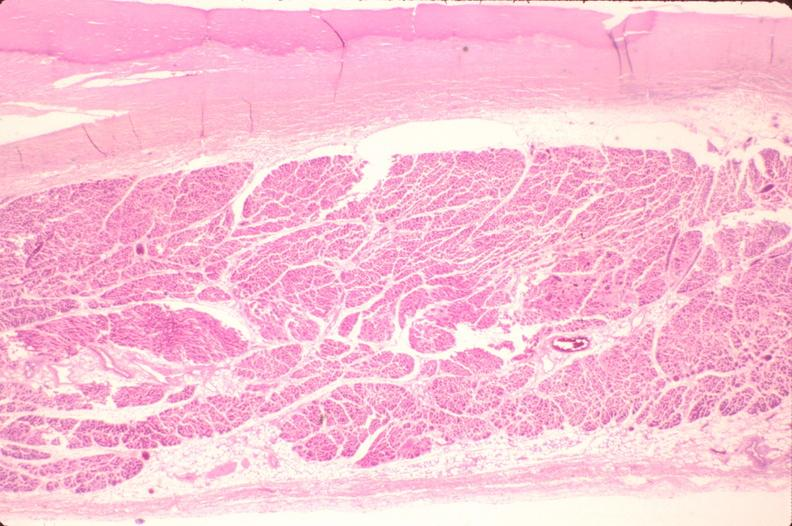what does this image show?
Answer the question using a single word or phrase. Heart 